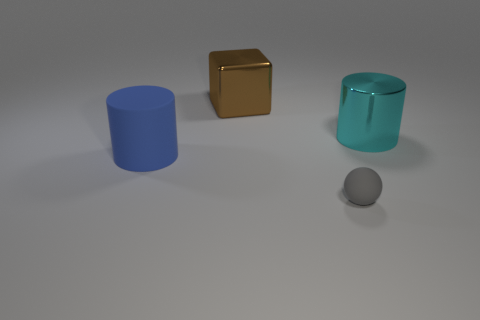Is there anything else that has the same size as the ball?
Keep it short and to the point. No. Is the number of rubber cylinders that are right of the big blue cylinder less than the number of large metallic blocks that are to the right of the shiny block?
Offer a terse response. No. What number of other objects are there of the same shape as the small gray matte object?
Keep it short and to the point. 0. What size is the gray matte ball in front of the big cylinder that is on the right side of the big cylinder in front of the cyan metallic thing?
Your answer should be very brief. Small. What number of cyan objects are rubber things or metallic cylinders?
Offer a terse response. 1. The blue thing that is on the left side of the metallic thing that is behind the cyan metal cylinder is what shape?
Offer a terse response. Cylinder. There is a metallic object to the left of the cyan cylinder; is its size the same as the matte thing right of the big blue matte object?
Make the answer very short. No. Is there a blue cylinder made of the same material as the tiny gray thing?
Keep it short and to the point. Yes. Is there a big cylinder on the left side of the metallic object to the left of the big cylinder that is to the right of the blue cylinder?
Keep it short and to the point. Yes. Are there any large metallic cylinders behind the brown block?
Offer a terse response. No. 